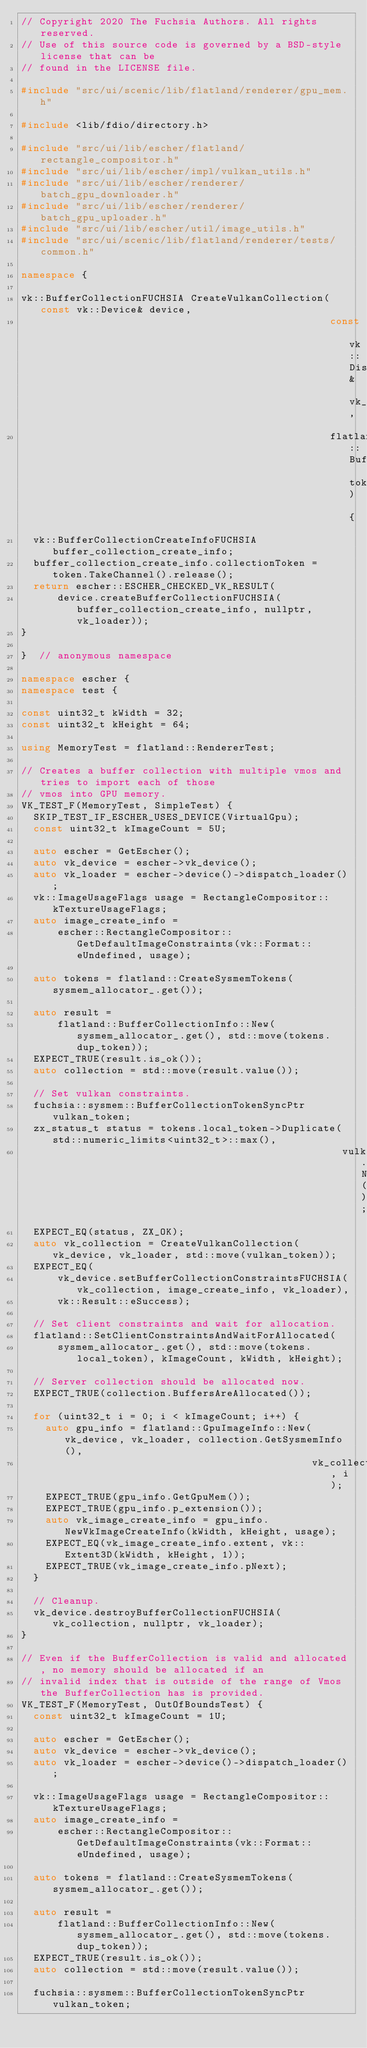Convert code to text. <code><loc_0><loc_0><loc_500><loc_500><_C++_>// Copyright 2020 The Fuchsia Authors. All rights reserved.
// Use of this source code is governed by a BSD-style license that can be
// found in the LICENSE file.

#include "src/ui/scenic/lib/flatland/renderer/gpu_mem.h"

#include <lib/fdio/directory.h>

#include "src/ui/lib/escher/flatland/rectangle_compositor.h"
#include "src/ui/lib/escher/impl/vulkan_utils.h"
#include "src/ui/lib/escher/renderer/batch_gpu_downloader.h"
#include "src/ui/lib/escher/renderer/batch_gpu_uploader.h"
#include "src/ui/lib/escher/util/image_utils.h"
#include "src/ui/scenic/lib/flatland/renderer/tests/common.h"

namespace {

vk::BufferCollectionFUCHSIA CreateVulkanCollection(const vk::Device& device,
                                                   const vk::DispatchLoaderDynamic& vk_loader,
                                                   flatland::BufferCollectionHandle token) {
  vk::BufferCollectionCreateInfoFUCHSIA buffer_collection_create_info;
  buffer_collection_create_info.collectionToken = token.TakeChannel().release();
  return escher::ESCHER_CHECKED_VK_RESULT(
      device.createBufferCollectionFUCHSIA(buffer_collection_create_info, nullptr, vk_loader));
}

}  // anonymous namespace

namespace escher {
namespace test {

const uint32_t kWidth = 32;
const uint32_t kHeight = 64;

using MemoryTest = flatland::RendererTest;

// Creates a buffer collection with multiple vmos and tries to import each of those
// vmos into GPU memory.
VK_TEST_F(MemoryTest, SimpleTest) {
  SKIP_TEST_IF_ESCHER_USES_DEVICE(VirtualGpu);
  const uint32_t kImageCount = 5U;

  auto escher = GetEscher();
  auto vk_device = escher->vk_device();
  auto vk_loader = escher->device()->dispatch_loader();
  vk::ImageUsageFlags usage = RectangleCompositor::kTextureUsageFlags;
  auto image_create_info =
      escher::RectangleCompositor::GetDefaultImageConstraints(vk::Format::eUndefined, usage);

  auto tokens = flatland::CreateSysmemTokens(sysmem_allocator_.get());

  auto result =
      flatland::BufferCollectionInfo::New(sysmem_allocator_.get(), std::move(tokens.dup_token));
  EXPECT_TRUE(result.is_ok());
  auto collection = std::move(result.value());

  // Set vulkan constraints.
  fuchsia::sysmem::BufferCollectionTokenSyncPtr vulkan_token;
  zx_status_t status = tokens.local_token->Duplicate(std::numeric_limits<uint32_t>::max(),
                                                     vulkan_token.NewRequest());
  EXPECT_EQ(status, ZX_OK);
  auto vk_collection = CreateVulkanCollection(vk_device, vk_loader, std::move(vulkan_token));
  EXPECT_EQ(
      vk_device.setBufferCollectionConstraintsFUCHSIA(vk_collection, image_create_info, vk_loader),
      vk::Result::eSuccess);

  // Set client constraints and wait for allocation.
  flatland::SetClientConstraintsAndWaitForAllocated(
      sysmem_allocator_.get(), std::move(tokens.local_token), kImageCount, kWidth, kHeight);

  // Server collection should be allocated now.
  EXPECT_TRUE(collection.BuffersAreAllocated());

  for (uint32_t i = 0; i < kImageCount; i++) {
    auto gpu_info = flatland::GpuImageInfo::New(vk_device, vk_loader, collection.GetSysmemInfo(),
                                                vk_collection, i);
    EXPECT_TRUE(gpu_info.GetGpuMem());
    EXPECT_TRUE(gpu_info.p_extension());
    auto vk_image_create_info = gpu_info.NewVkImageCreateInfo(kWidth, kHeight, usage);
    EXPECT_EQ(vk_image_create_info.extent, vk::Extent3D(kWidth, kHeight, 1));
    EXPECT_TRUE(vk_image_create_info.pNext);
  }

  // Cleanup.
  vk_device.destroyBufferCollectionFUCHSIA(vk_collection, nullptr, vk_loader);
}

// Even if the BufferCollection is valid and allocated, no memory should be allocated if an
// invalid index that is outside of the range of Vmos the BufferCollection has is provided.
VK_TEST_F(MemoryTest, OutOfBoundsTest) {
  const uint32_t kImageCount = 1U;

  auto escher = GetEscher();
  auto vk_device = escher->vk_device();
  auto vk_loader = escher->device()->dispatch_loader();

  vk::ImageUsageFlags usage = RectangleCompositor::kTextureUsageFlags;
  auto image_create_info =
      escher::RectangleCompositor::GetDefaultImageConstraints(vk::Format::eUndefined, usage);

  auto tokens = flatland::CreateSysmemTokens(sysmem_allocator_.get());

  auto result =
      flatland::BufferCollectionInfo::New(sysmem_allocator_.get(), std::move(tokens.dup_token));
  EXPECT_TRUE(result.is_ok());
  auto collection = std::move(result.value());

  fuchsia::sysmem::BufferCollectionTokenSyncPtr vulkan_token;</code> 